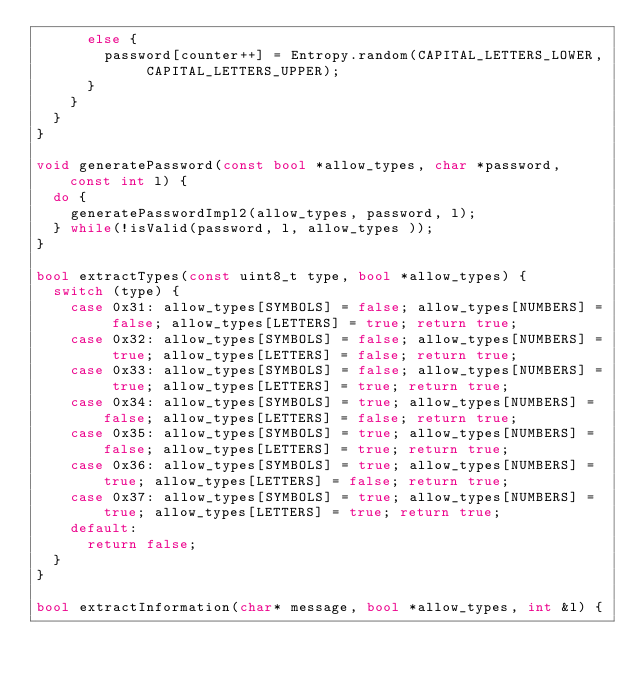<code> <loc_0><loc_0><loc_500><loc_500><_C++_>      else {
        password[counter++] = Entropy.random(CAPITAL_LETTERS_LOWER, CAPITAL_LETTERS_UPPER);
      }
    }
  }
}

void generatePassword(const bool *allow_types, char *password, const int l) {
  do {
    generatePasswordImpl2(allow_types, password, l);
  } while(!isValid(password, l, allow_types ));
}

bool extractTypes(const uint8_t type, bool *allow_types) {
  switch (type) {
    case 0x31: allow_types[SYMBOLS] = false; allow_types[NUMBERS] = false; allow_types[LETTERS] = true; return true;
    case 0x32: allow_types[SYMBOLS] = false; allow_types[NUMBERS] = true; allow_types[LETTERS] = false; return true;
    case 0x33: allow_types[SYMBOLS] = false; allow_types[NUMBERS] = true; allow_types[LETTERS] = true; return true;
    case 0x34: allow_types[SYMBOLS] = true; allow_types[NUMBERS] = false; allow_types[LETTERS] = false; return true;
    case 0x35: allow_types[SYMBOLS] = true; allow_types[NUMBERS] = false; allow_types[LETTERS] = true; return true;
    case 0x36: allow_types[SYMBOLS] = true; allow_types[NUMBERS] = true; allow_types[LETTERS] = false; return true;
    case 0x37: allow_types[SYMBOLS] = true; allow_types[NUMBERS] = true; allow_types[LETTERS] = true; return true;
    default:
      return false;
  }
}

bool extractInformation(char* message, bool *allow_types, int &l) {</code> 